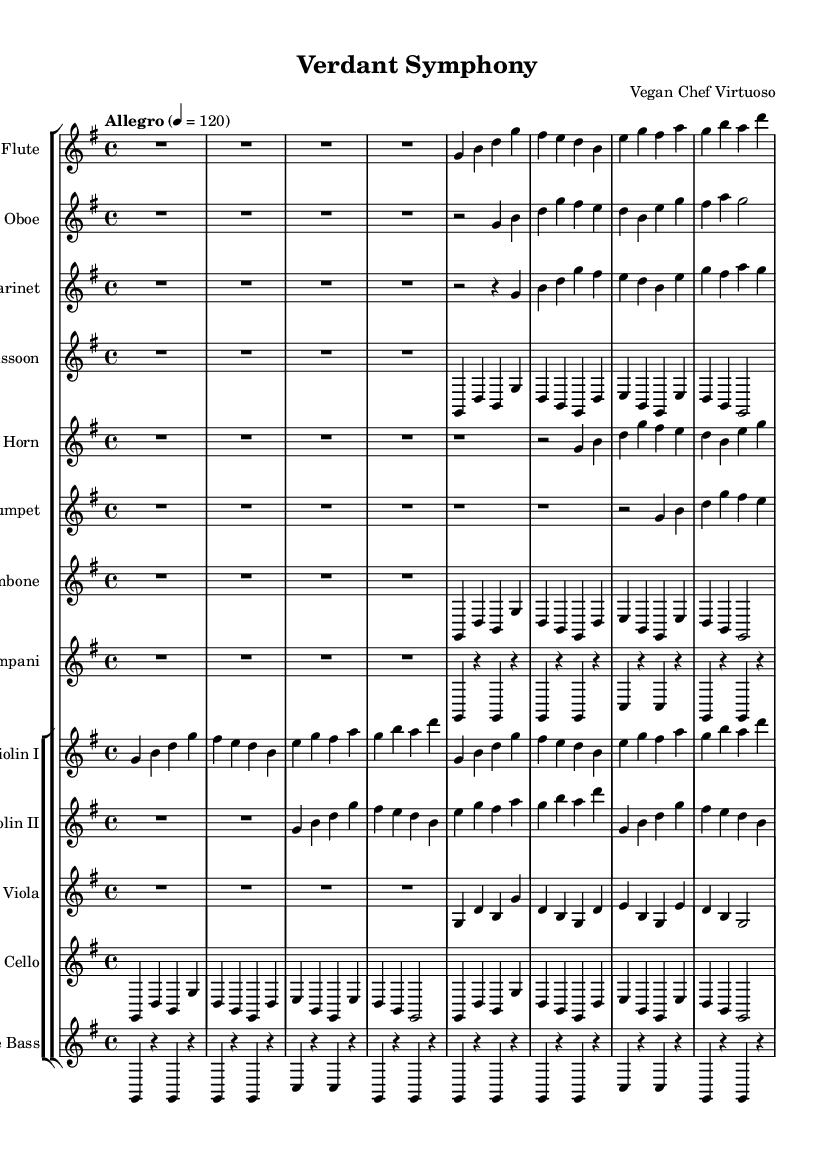What is the key signature of this music? The key signature is G major, which has one sharp (F#). This information can be found at the beginning of the sheet music where the key signature is indicated.
Answer: G major What is the time signature in this sheet music? The time signature is 4/4, indicating that there are four beats per measure and the quarter note gets one beat. This is indicated at the beginning of the score.
Answer: 4/4 What is the tempo marking in this piece? The tempo marking indicates "Allegro," which suggests a fast and lively pace. This marking is shown above the staff in the score.
Answer: Allegro Which instruments are featured in this symphony? The instruments featured in this symphony include flute, oboe, clarinet, bassoon, horn, trumpet, trombone, timpani, violin I, violin II, viola, cello, and double bass. This can be determined by reading the names of the staves at the beginning of the score.
Answer: Flute, Oboe, Clarinet, Bassoon, Horn, Trumpet, Trombone, Timpani, Violin I, Violin II, Viola, Cello, Double Bass How many measures are in the flute part? To find the total number of measures in the flute part, I can count each measure across the written music. There are four full measures visible in the presented flute part.
Answer: 4 What is the dynamic level indicated in the piece? The dynamic level is not explicitly shown in the provided sheet music, therefore I cannot directly respond to this question with information found in the music. Since it's absent, the answer is nonexistent.
Answer: None Where does the violin I part start in the score? The violin I part begins after the woodwind and brass staves and just before the violin II part in the orchestral arrangement. This can be gauged from the layout of the staff groups in the score.
Answer: After the woodwinds 